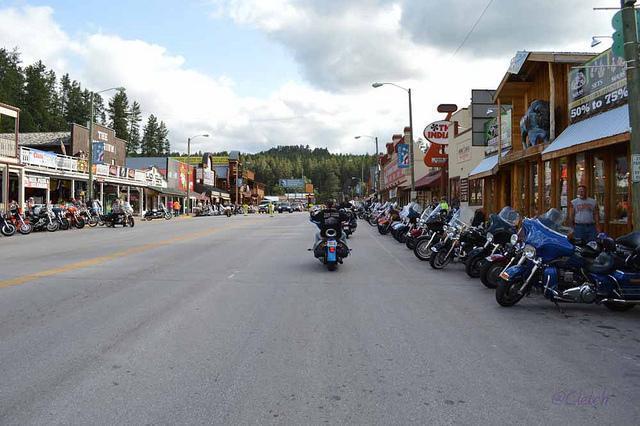How many motorcycles are visible?
Give a very brief answer. 2. 